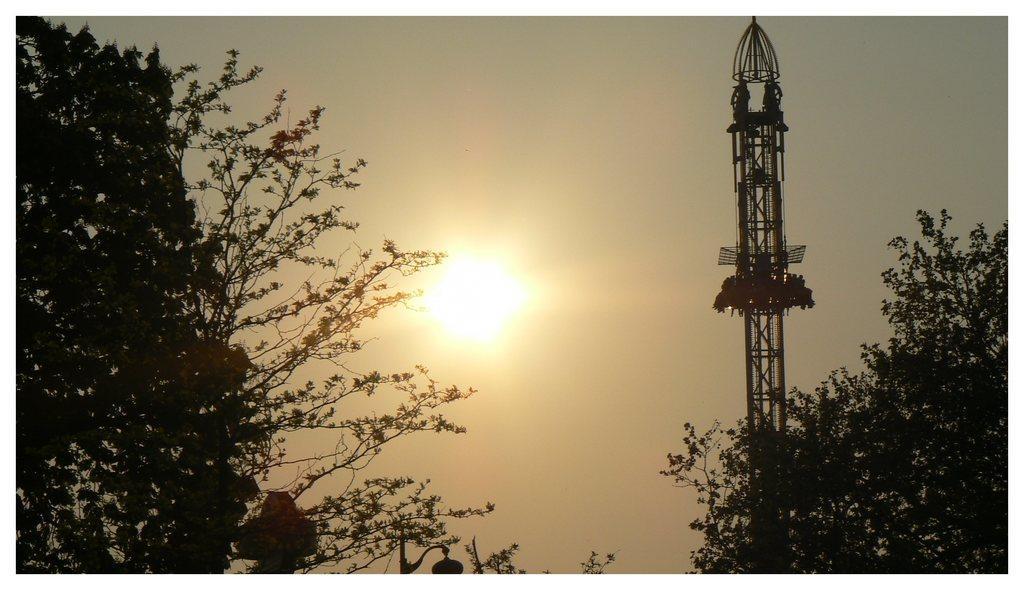Can you describe this image briefly? In the center of the image we can see a sun. In the background of the image we can see trees, lights, poles, tower are there. At the top of the image there is a sky. 